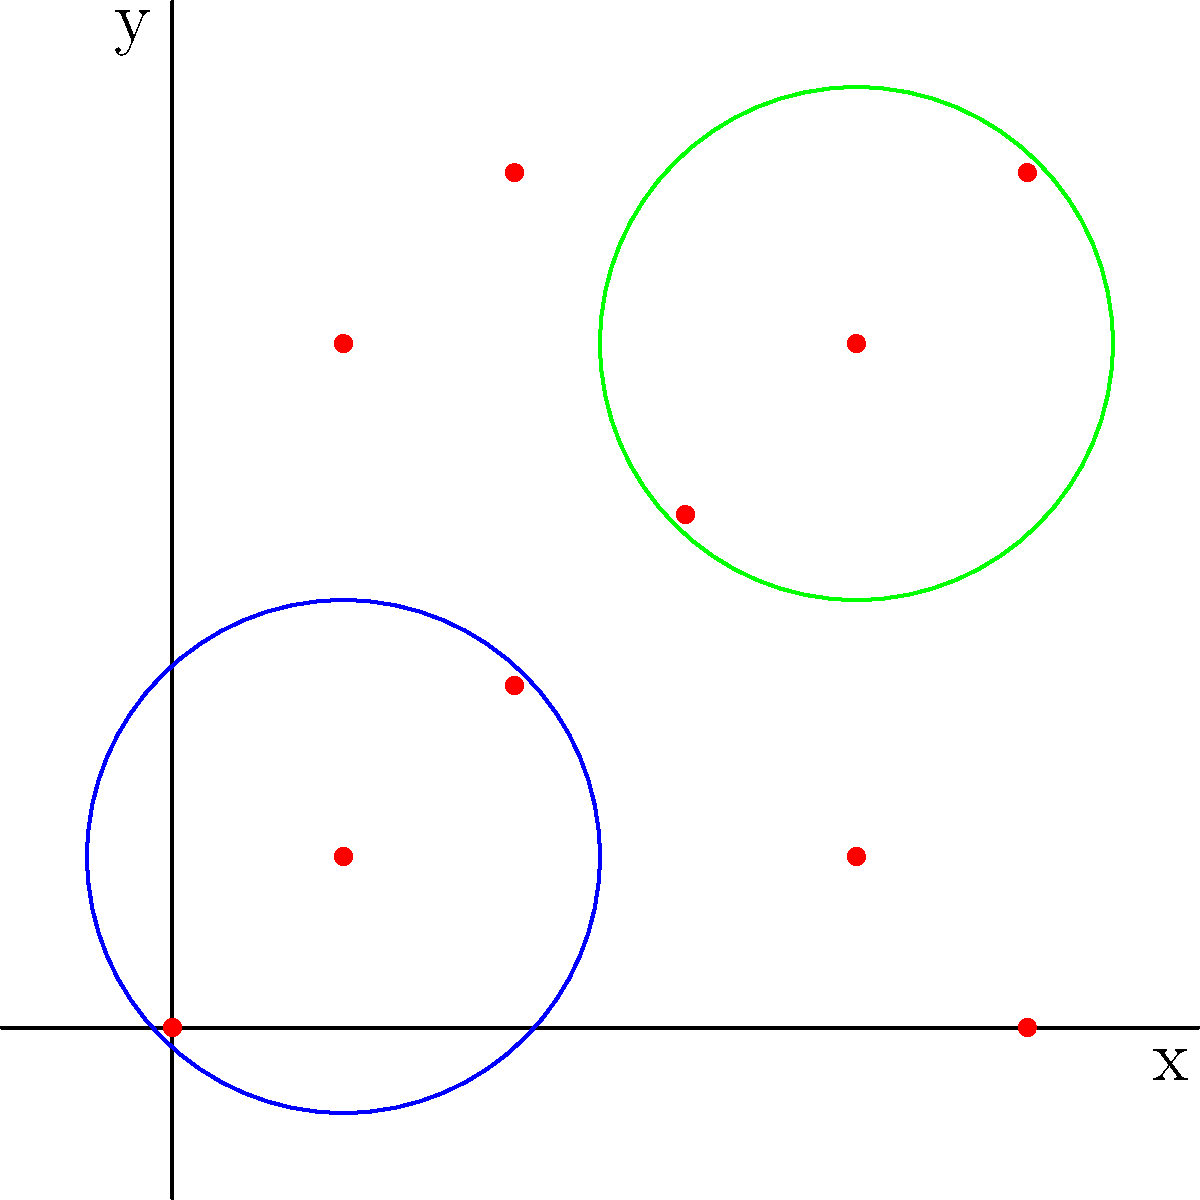In the given map, points of interest are represented as red dots. Two clusters have been identified and marked with blue and green circles. Which clustering algorithm would be most appropriate for identifying these clusters based on their spatial distribution and potential attributes (such as type of location or user ratings)? To determine the most appropriate clustering algorithm for this scenario, let's consider the characteristics of the data and the requirements of our crowdsourced mapping application:

1. Spatial distribution: The points are distributed in a 2D space, representing geographical locations on a map.

2. Potential attributes: Each point may have additional attributes like type of location or user ratings.

3. Cluster shape: The clusters appear to be roughly circular and of similar size.

4. Number of clusters: The number of clusters is not predetermined and may vary based on the data.

5. Scalability: As a crowdsourced application, the algorithm should be able to handle a growing number of points efficiently.

Given these factors, we can evaluate some common clustering algorithms:

a) K-means: Requires a predefined number of clusters and works best with spherical clusters. However, it doesn't inherently consider spatial relationships.

b) DBSCAN (Density-Based Spatial Clustering of Applications with Noise): Works well with spatial data and can identify clusters of arbitrary shapes. It doesn't require a predefined number of clusters and can handle noise points.

c) Hierarchical clustering: Can work with spatial data but may be computationally expensive for large datasets.

d) OPTICS (Ordering Points To Identify the Clustering Structure): Similar to DBSCAN but can handle varying density clusters more effectively.

Considering these options, DBSCAN would be the most appropriate choice for this scenario because:

1. It naturally handles spatial data.
2. It can discover clusters of arbitrary shapes and sizes.
3. It doesn't require a predefined number of clusters.
4. It can identify noise points, which is useful for filtering out irrelevant data.
5. It has relatively good scalability for large datasets.

DBSCAN can also be extended to consider additional attributes alongside spatial information, making it suitable for incorporating factors like location type or user ratings in the clustering process.
Answer: DBSCAN (Density-Based Spatial Clustering of Applications with Noise) 